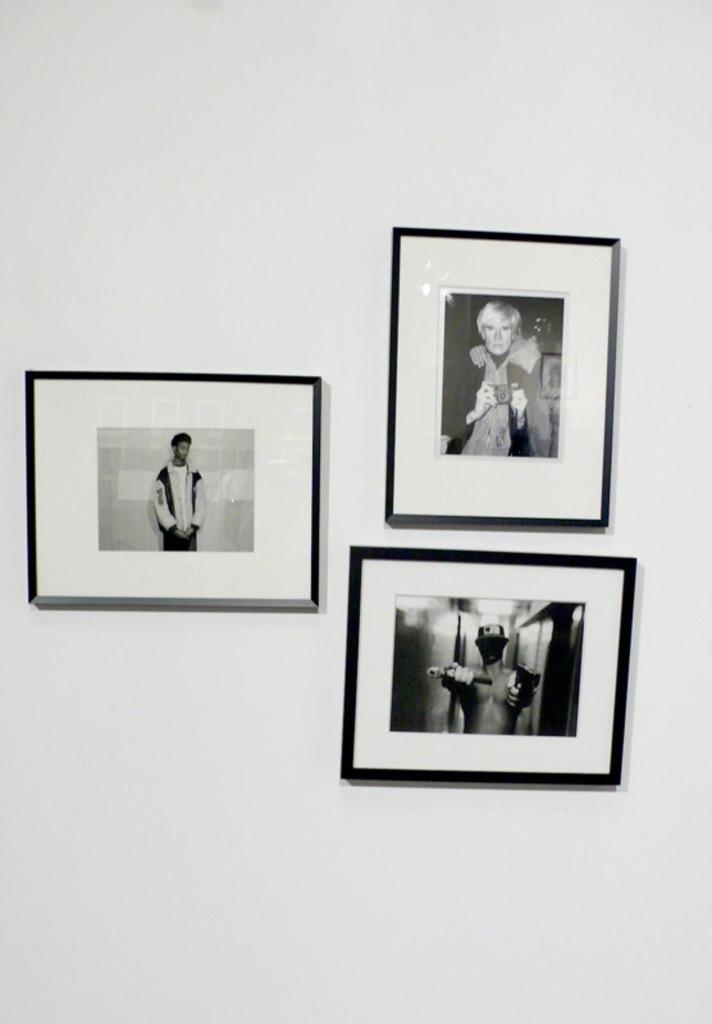How many photo frames are visible in the image? There are three photo frames in the image. What is the color of the background on which the photo frames are attached? The photo frames are attached to a white background. How many people are smiling with their legs crossed in the image? There are no people present in the image, so it is not possible to determine how many people are smiling or crossing their legs. 